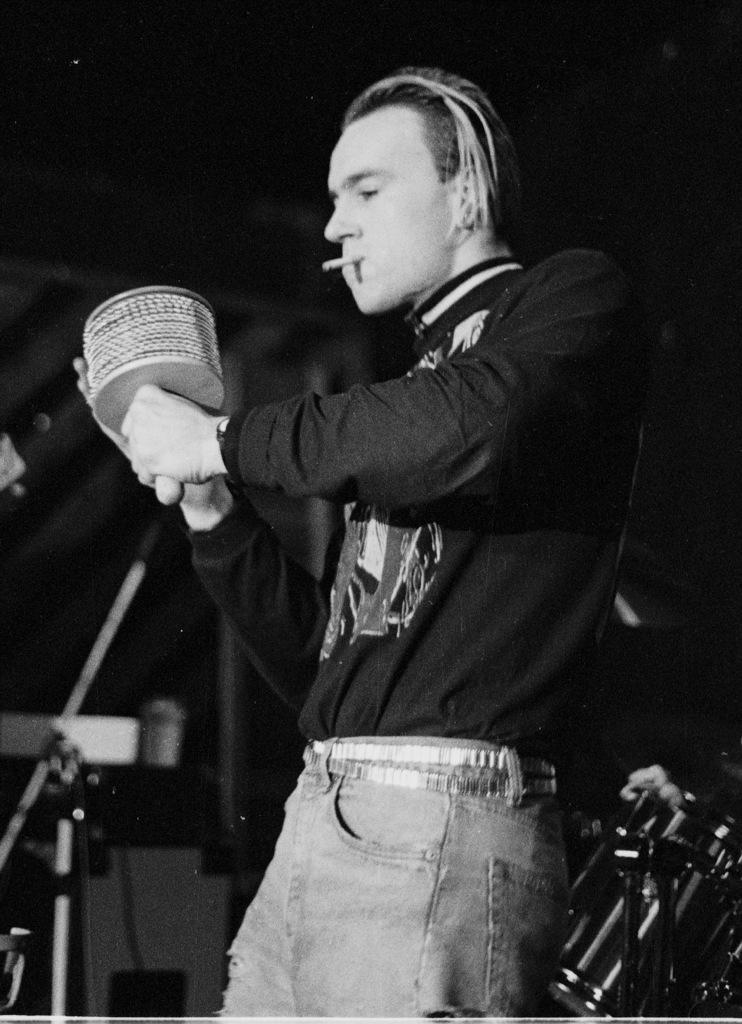What is the man in the image doing? The man is standing in the image and smoking. What is the man holding in his hand? The man is holding something in his hand, but the specific object is not clear from the image. What else can be seen in the image besides the man? There are instruments visible in the image. What type of apparatus is the man using to play with the balls in the image? There is no apparatus or balls present in the image. 